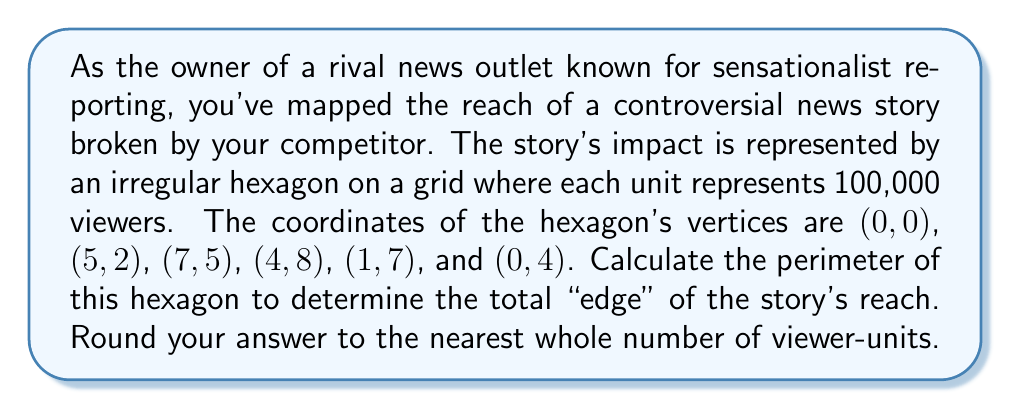Can you answer this question? To solve this problem, we need to follow these steps:

1. Identify the coordinates of each vertex.
2. Calculate the distance between each pair of consecutive vertices.
3. Sum up all these distances to get the perimeter.
4. Convert the result to viewer-units and round to the nearest whole number.

Let's calculate each side length using the distance formula:
$d = \sqrt{(x_2-x_1)^2 + (y_2-y_1)^2}$

Side 1: (0,0) to (5,2)
$$d_1 = \sqrt{(5-0)^2 + (2-0)^2} = \sqrt{25 + 4} = \sqrt{29}$$

Side 2: (5,2) to (7,5)
$$d_2 = \sqrt{(7-5)^2 + (5-2)^2} = \sqrt{4 + 9} = \sqrt{13}$$

Side 3: (7,5) to (4,8)
$$d_3 = \sqrt{(4-7)^2 + (8-5)^2} = \sqrt{9 + 9} = \sqrt{18} = 3\sqrt{2}$$

Side 4: (4,8) to (1,7)
$$d_4 = \sqrt{(1-4)^2 + (7-8)^2} = \sqrt{9 + 1} = \sqrt{10}$$

Side 5: (1,7) to (0,4)
$$d_5 = \sqrt{(0-1)^2 + (4-7)^2} = \sqrt{1 + 9} = \sqrt{10}$$

Side 6: (0,4) to (0,0)
$$d_6 = \sqrt{(0-0)^2 + (0-4)^2} = 4$$

Now, let's sum up all these distances:
$$\text{Perimeter} = \sqrt{29} + \sqrt{13} + 3\sqrt{2} + \sqrt{10} + \sqrt{10} + 4$$

Using a calculator and rounding to 4 decimal places:
$$\text{Perimeter} \approx 5.3852 + 3.6056 + 4.2426 + 3.1623 + 3.1623 + 4.0000 = 23.5580$$

Each unit represents 100,000 viewers, so we multiply by 100,000:
$$23.5580 \times 100,000 = 2,355,800 \text{ viewer-units}$$

Rounding to the nearest whole number of viewer-units:
$$2,356,000 \text{ viewer-units}$$
Answer: The perimeter of the irregular hexagon representing the controversial news story's reach is approximately 2,356,000 viewer-units. 